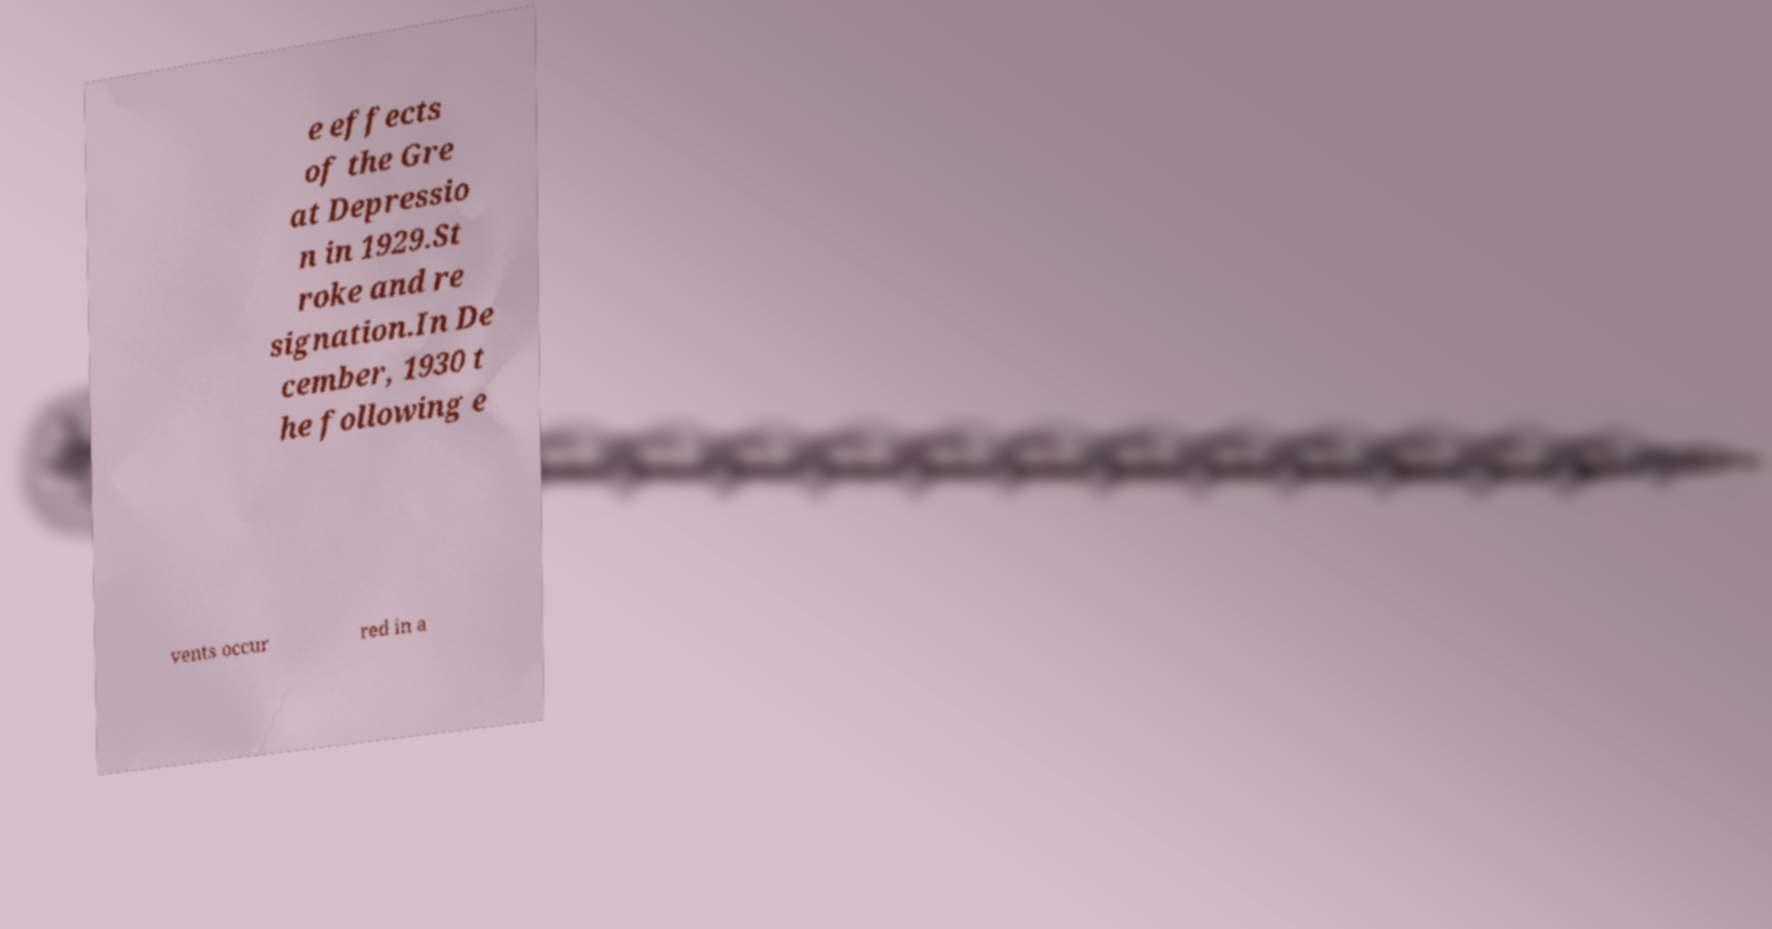For documentation purposes, I need the text within this image transcribed. Could you provide that? e effects of the Gre at Depressio n in 1929.St roke and re signation.In De cember, 1930 t he following e vents occur red in a 